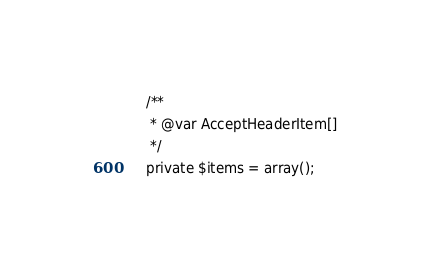<code> <loc_0><loc_0><loc_500><loc_500><_PHP_>	/**
	 * @var AcceptHeaderItem[]
	 */
	private $items = array();
</code> 